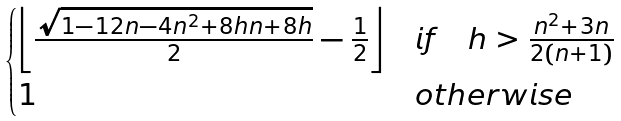Convert formula to latex. <formula><loc_0><loc_0><loc_500><loc_500>\begin{cases} \left \lfloor \frac { \sqrt { 1 - 1 2 n - 4 n ^ { 2 } + 8 h n + 8 h } } { 2 } - \frac { 1 } { 2 } \right \rfloor & i f \quad h > \frac { n ^ { 2 } + 3 n } { 2 ( n + 1 ) } \\ 1 & o t h e r w i s e \end{cases}</formula> 